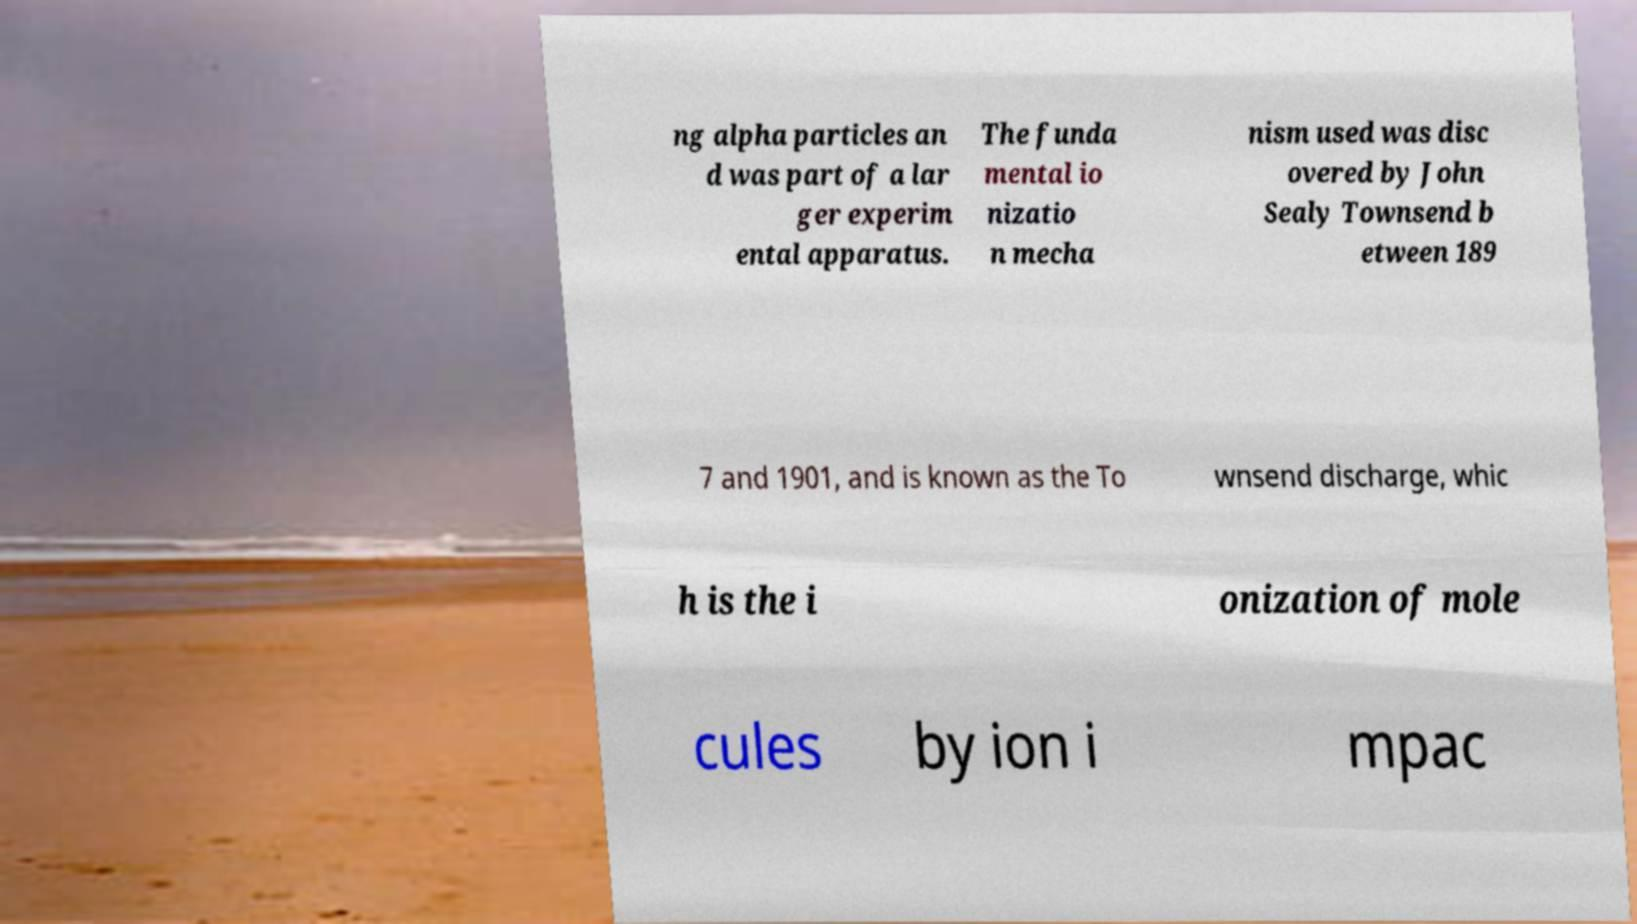Can you read and provide the text displayed in the image?This photo seems to have some interesting text. Can you extract and type it out for me? ng alpha particles an d was part of a lar ger experim ental apparatus. The funda mental io nizatio n mecha nism used was disc overed by John Sealy Townsend b etween 189 7 and 1901, and is known as the To wnsend discharge, whic h is the i onization of mole cules by ion i mpac 